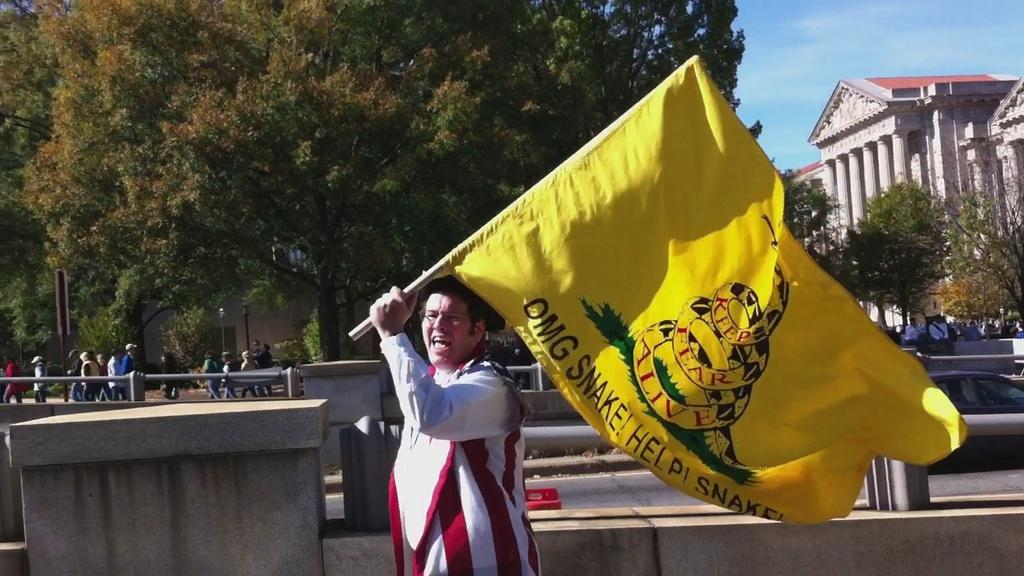<image>
Present a compact description of the photo's key features. A man dressed as a patriot waves a yellow flag with a Keep Fear Alive message. 